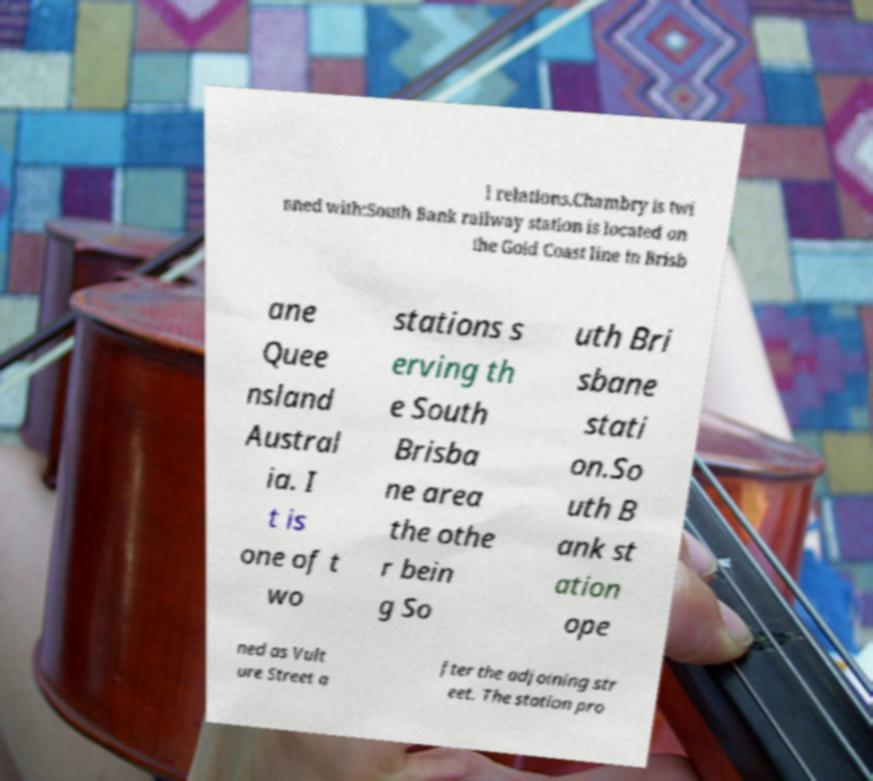Can you accurately transcribe the text from the provided image for me? l relations.Chambry is twi nned with:South Bank railway station is located on the Gold Coast line in Brisb ane Quee nsland Austral ia. I t is one of t wo stations s erving th e South Brisba ne area the othe r bein g So uth Bri sbane stati on.So uth B ank st ation ope ned as Vult ure Street a fter the adjoining str eet. The station pro 